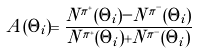Convert formula to latex. <formula><loc_0><loc_0><loc_500><loc_500>A ( \Theta _ { i } ) = \frac { N ^ { \pi ^ { + } } ( \Theta _ { i } ) - N ^ { \pi ^ { - } } ( \Theta _ { i } ) } { N ^ { \pi ^ { + } } ( \Theta _ { i } ) + N ^ { \pi ^ { - } } ( \Theta _ { i } ) }</formula> 